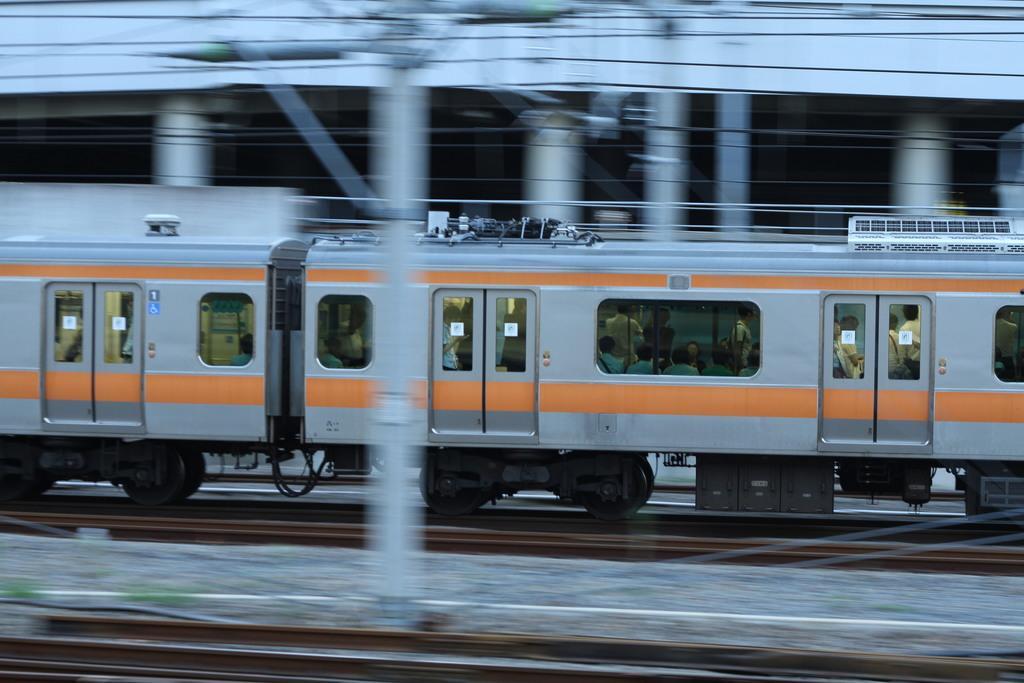How would you summarize this image in a sentence or two? In this picture, there is a train on the track. The train is in grey and orange in color. In the train there are people. At the bottom, there is another track. 